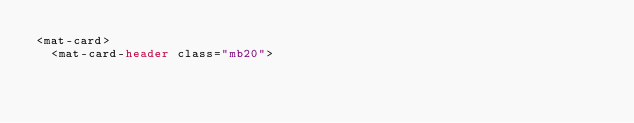Convert code to text. <code><loc_0><loc_0><loc_500><loc_500><_HTML_><mat-card>
  <mat-card-header class="mb20"></code> 